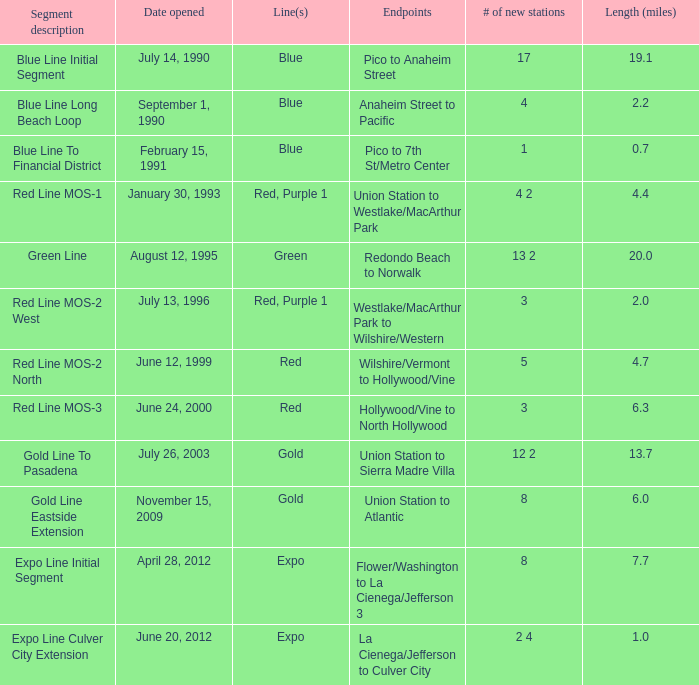How many rows are in the segment description of red line mos-2 west? Red, Purple 1. 